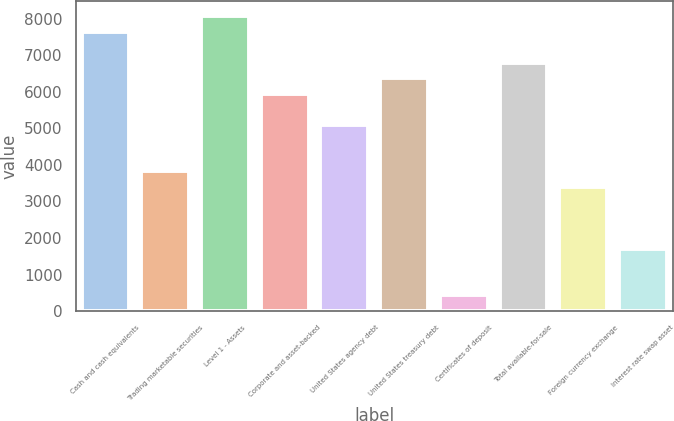Convert chart. <chart><loc_0><loc_0><loc_500><loc_500><bar_chart><fcel>Cash and cash equivalents<fcel>Trading marketable securities<fcel>Level 1 - Assets<fcel>Corporate and asset-backed<fcel>United States agency debt<fcel>United States treasury debt<fcel>Certificates of deposit<fcel>Total available-for-sale<fcel>Foreign currency exchange<fcel>Interest rate swap asset<nl><fcel>7642.2<fcel>3822.6<fcel>8066.6<fcel>5944.6<fcel>5095.8<fcel>6369<fcel>427.4<fcel>6793.4<fcel>3398.2<fcel>1700.6<nl></chart> 